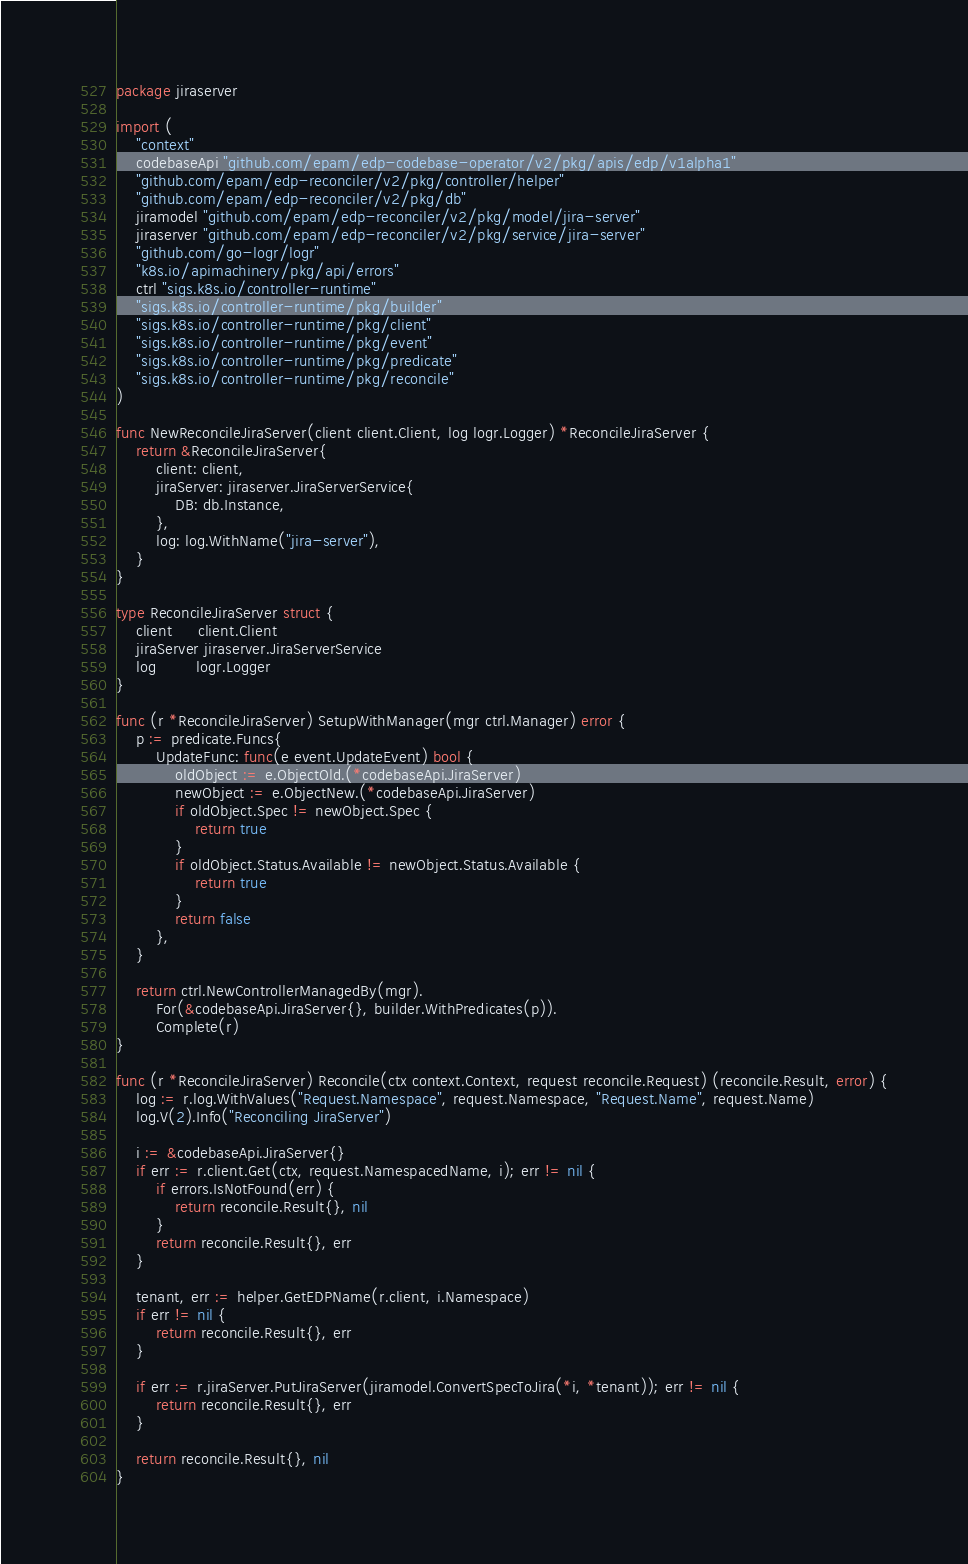<code> <loc_0><loc_0><loc_500><loc_500><_Go_>package jiraserver

import (
	"context"
	codebaseApi "github.com/epam/edp-codebase-operator/v2/pkg/apis/edp/v1alpha1"
	"github.com/epam/edp-reconciler/v2/pkg/controller/helper"
	"github.com/epam/edp-reconciler/v2/pkg/db"
	jiramodel "github.com/epam/edp-reconciler/v2/pkg/model/jira-server"
	jiraserver "github.com/epam/edp-reconciler/v2/pkg/service/jira-server"
	"github.com/go-logr/logr"
	"k8s.io/apimachinery/pkg/api/errors"
	ctrl "sigs.k8s.io/controller-runtime"
	"sigs.k8s.io/controller-runtime/pkg/builder"
	"sigs.k8s.io/controller-runtime/pkg/client"
	"sigs.k8s.io/controller-runtime/pkg/event"
	"sigs.k8s.io/controller-runtime/pkg/predicate"
	"sigs.k8s.io/controller-runtime/pkg/reconcile"
)

func NewReconcileJiraServer(client client.Client, log logr.Logger) *ReconcileJiraServer {
	return &ReconcileJiraServer{
		client: client,
		jiraServer: jiraserver.JiraServerService{
			DB: db.Instance,
		},
		log: log.WithName("jira-server"),
	}
}

type ReconcileJiraServer struct {
	client     client.Client
	jiraServer jiraserver.JiraServerService
	log        logr.Logger
}

func (r *ReconcileJiraServer) SetupWithManager(mgr ctrl.Manager) error {
	p := predicate.Funcs{
		UpdateFunc: func(e event.UpdateEvent) bool {
			oldObject := e.ObjectOld.(*codebaseApi.JiraServer)
			newObject := e.ObjectNew.(*codebaseApi.JiraServer)
			if oldObject.Spec != newObject.Spec {
				return true
			}
			if oldObject.Status.Available != newObject.Status.Available {
				return true
			}
			return false
		},
	}

	return ctrl.NewControllerManagedBy(mgr).
		For(&codebaseApi.JiraServer{}, builder.WithPredicates(p)).
		Complete(r)
}

func (r *ReconcileJiraServer) Reconcile(ctx context.Context, request reconcile.Request) (reconcile.Result, error) {
	log := r.log.WithValues("Request.Namespace", request.Namespace, "Request.Name", request.Name)
	log.V(2).Info("Reconciling JiraServer")

	i := &codebaseApi.JiraServer{}
	if err := r.client.Get(ctx, request.NamespacedName, i); err != nil {
		if errors.IsNotFound(err) {
			return reconcile.Result{}, nil
		}
		return reconcile.Result{}, err
	}

	tenant, err := helper.GetEDPName(r.client, i.Namespace)
	if err != nil {
		return reconcile.Result{}, err
	}

	if err := r.jiraServer.PutJiraServer(jiramodel.ConvertSpecToJira(*i, *tenant)); err != nil {
		return reconcile.Result{}, err
	}

	return reconcile.Result{}, nil
}
</code> 